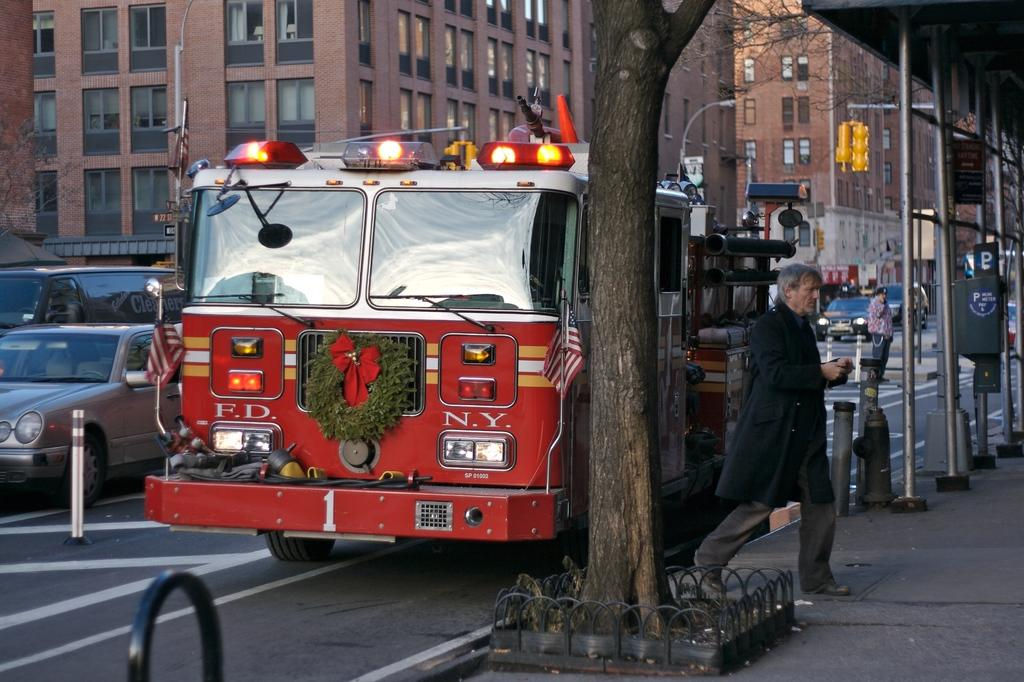What is the main subject in the middle of the image? There is a tree in the middle of the image. What can be seen behind the tree? There are vehicles on the road behind the tree. What are the people in the image doing? There are people walking in the area. What other objects can be seen in the image? There are poles visible in the image. What is visible in the background of the image? There are trees and buildings in the background. What type of cord is being used by the writer in the image? There is no writer or cord present in the image. 